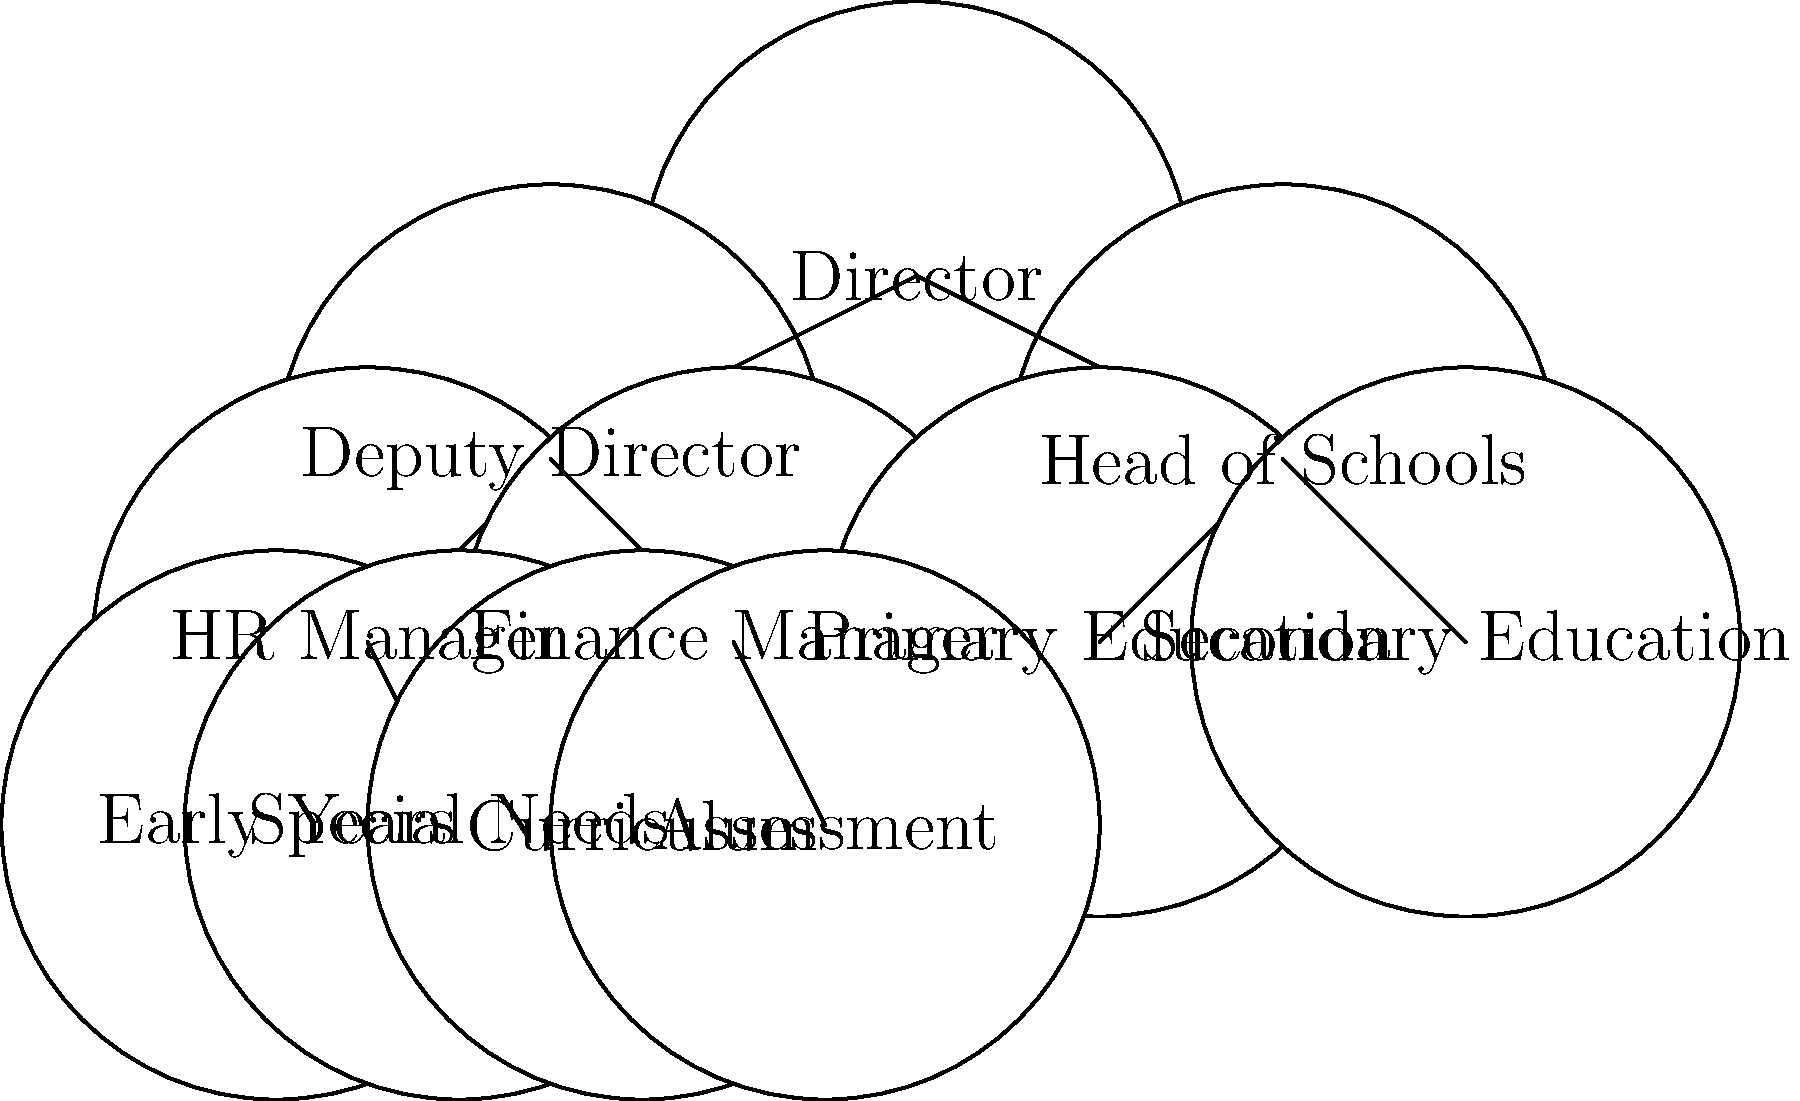In the organizational structure of North Yorkshire's education department, which division is directly responsible for overseeing both Primary and Secondary Education? To answer this question, let's analyze the hierarchical tree diagram step-by-step:

1. At the top of the hierarchy is the Director of the education department.

2. Directly under the Director, we see two main branches:
   a) Deputy Director
   b) Head of Schools

3. Under the Deputy Director, we find:
   - HR Manager
   - Finance Manager

4. Under the Head of Schools, we see:
   - Primary Education
   - Secondary Education

5. The Primary Education branch further divides into:
   - Early Years
   - Special Needs

6. The Secondary Education branch further divides into:
   - Curriculum
   - Assessment

From this structure, we can conclude that the division directly responsible for overseeing both Primary and Secondary Education is the Head of Schools. This position is at the second level of the hierarchy and has direct lines connecting to both Primary and Secondary Education divisions.
Answer: Head of Schools 